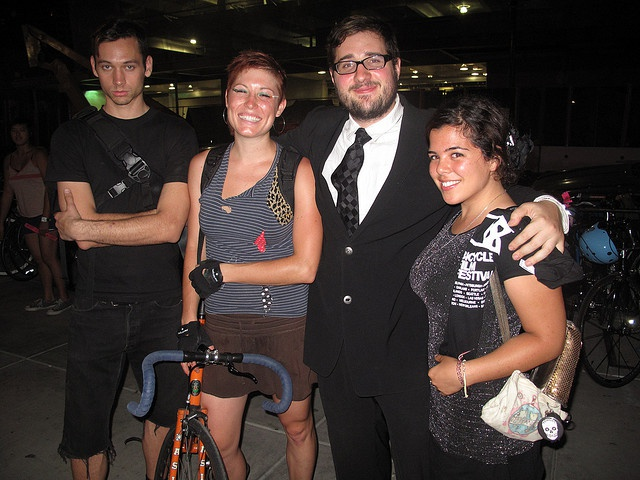Describe the objects in this image and their specific colors. I can see people in black, brown, maroon, and gray tones, people in black, tan, gray, and salmon tones, people in black, white, gray, and brown tones, people in black, gray, maroon, and salmon tones, and bicycle in black, gray, maroon, and red tones in this image. 